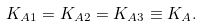Convert formula to latex. <formula><loc_0><loc_0><loc_500><loc_500>K _ { A 1 } = K _ { A 2 } = K _ { A 3 } \equiv K _ { A } .</formula> 